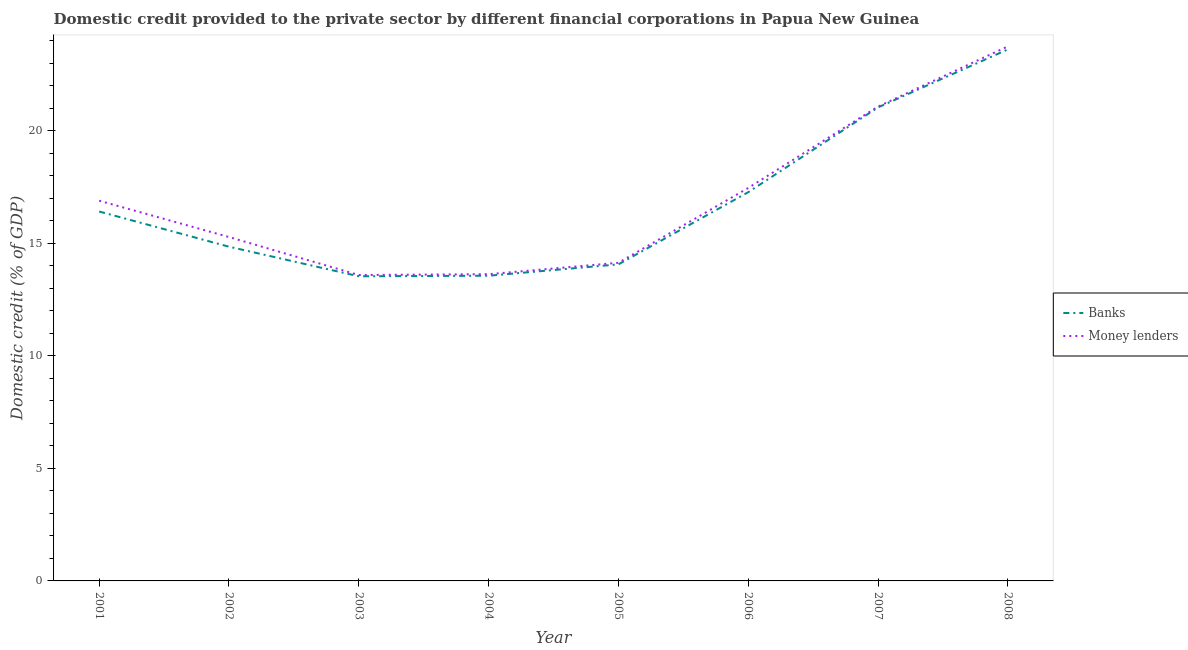Is the number of lines equal to the number of legend labels?
Make the answer very short. Yes. What is the domestic credit provided by money lenders in 2004?
Your answer should be compact. 13.62. Across all years, what is the maximum domestic credit provided by money lenders?
Offer a very short reply. 23.74. Across all years, what is the minimum domestic credit provided by money lenders?
Offer a terse response. 13.59. In which year was the domestic credit provided by money lenders maximum?
Your answer should be very brief. 2008. In which year was the domestic credit provided by banks minimum?
Your answer should be compact. 2003. What is the total domestic credit provided by banks in the graph?
Keep it short and to the point. 134.3. What is the difference between the domestic credit provided by money lenders in 2002 and that in 2008?
Give a very brief answer. -8.47. What is the difference between the domestic credit provided by money lenders in 2008 and the domestic credit provided by banks in 2002?
Offer a very short reply. 8.9. What is the average domestic credit provided by banks per year?
Ensure brevity in your answer.  16.79. In the year 2002, what is the difference between the domestic credit provided by money lenders and domestic credit provided by banks?
Your response must be concise. 0.43. In how many years, is the domestic credit provided by money lenders greater than 9 %?
Offer a terse response. 8. What is the ratio of the domestic credit provided by banks in 2002 to that in 2008?
Provide a short and direct response. 0.63. Is the difference between the domestic credit provided by money lenders in 2004 and 2005 greater than the difference between the domestic credit provided by banks in 2004 and 2005?
Offer a terse response. No. What is the difference between the highest and the second highest domestic credit provided by money lenders?
Keep it short and to the point. 2.67. What is the difference between the highest and the lowest domestic credit provided by banks?
Your answer should be compact. 10.08. Is the domestic credit provided by money lenders strictly greater than the domestic credit provided by banks over the years?
Offer a terse response. Yes. Are the values on the major ticks of Y-axis written in scientific E-notation?
Give a very brief answer. No. Does the graph contain any zero values?
Offer a terse response. No. How are the legend labels stacked?
Your answer should be very brief. Vertical. What is the title of the graph?
Offer a terse response. Domestic credit provided to the private sector by different financial corporations in Papua New Guinea. Does "Age 65(female)" appear as one of the legend labels in the graph?
Ensure brevity in your answer.  No. What is the label or title of the X-axis?
Provide a succinct answer. Year. What is the label or title of the Y-axis?
Provide a short and direct response. Domestic credit (% of GDP). What is the Domestic credit (% of GDP) in Banks in 2001?
Your answer should be compact. 16.41. What is the Domestic credit (% of GDP) of Money lenders in 2001?
Offer a very short reply. 16.89. What is the Domestic credit (% of GDP) in Banks in 2002?
Offer a very short reply. 14.84. What is the Domestic credit (% of GDP) in Money lenders in 2002?
Make the answer very short. 15.27. What is the Domestic credit (% of GDP) of Banks in 2003?
Provide a short and direct response. 13.53. What is the Domestic credit (% of GDP) in Money lenders in 2003?
Your answer should be very brief. 13.59. What is the Domestic credit (% of GDP) in Banks in 2004?
Your response must be concise. 13.56. What is the Domestic credit (% of GDP) in Money lenders in 2004?
Give a very brief answer. 13.62. What is the Domestic credit (% of GDP) in Banks in 2005?
Offer a very short reply. 14.06. What is the Domestic credit (% of GDP) of Money lenders in 2005?
Keep it short and to the point. 14.13. What is the Domestic credit (% of GDP) in Banks in 2006?
Provide a short and direct response. 17.27. What is the Domestic credit (% of GDP) in Money lenders in 2006?
Provide a short and direct response. 17.45. What is the Domestic credit (% of GDP) of Banks in 2007?
Provide a short and direct response. 21.03. What is the Domestic credit (% of GDP) in Money lenders in 2007?
Offer a very short reply. 21.07. What is the Domestic credit (% of GDP) in Banks in 2008?
Offer a very short reply. 23.61. What is the Domestic credit (% of GDP) in Money lenders in 2008?
Keep it short and to the point. 23.74. Across all years, what is the maximum Domestic credit (% of GDP) of Banks?
Offer a very short reply. 23.61. Across all years, what is the maximum Domestic credit (% of GDP) in Money lenders?
Provide a short and direct response. 23.74. Across all years, what is the minimum Domestic credit (% of GDP) in Banks?
Provide a succinct answer. 13.53. Across all years, what is the minimum Domestic credit (% of GDP) in Money lenders?
Give a very brief answer. 13.59. What is the total Domestic credit (% of GDP) in Banks in the graph?
Offer a very short reply. 134.3. What is the total Domestic credit (% of GDP) in Money lenders in the graph?
Give a very brief answer. 135.76. What is the difference between the Domestic credit (% of GDP) in Banks in 2001 and that in 2002?
Give a very brief answer. 1.56. What is the difference between the Domestic credit (% of GDP) of Money lenders in 2001 and that in 2002?
Your answer should be compact. 1.61. What is the difference between the Domestic credit (% of GDP) in Banks in 2001 and that in 2003?
Give a very brief answer. 2.88. What is the difference between the Domestic credit (% of GDP) of Banks in 2001 and that in 2004?
Provide a succinct answer. 2.85. What is the difference between the Domestic credit (% of GDP) in Money lenders in 2001 and that in 2004?
Your answer should be compact. 3.26. What is the difference between the Domestic credit (% of GDP) of Banks in 2001 and that in 2005?
Offer a very short reply. 2.35. What is the difference between the Domestic credit (% of GDP) of Money lenders in 2001 and that in 2005?
Your answer should be compact. 2.76. What is the difference between the Domestic credit (% of GDP) in Banks in 2001 and that in 2006?
Give a very brief answer. -0.86. What is the difference between the Domestic credit (% of GDP) of Money lenders in 2001 and that in 2006?
Offer a very short reply. -0.57. What is the difference between the Domestic credit (% of GDP) in Banks in 2001 and that in 2007?
Offer a very short reply. -4.62. What is the difference between the Domestic credit (% of GDP) of Money lenders in 2001 and that in 2007?
Offer a terse response. -4.18. What is the difference between the Domestic credit (% of GDP) in Banks in 2001 and that in 2008?
Make the answer very short. -7.2. What is the difference between the Domestic credit (% of GDP) of Money lenders in 2001 and that in 2008?
Give a very brief answer. -6.86. What is the difference between the Domestic credit (% of GDP) in Banks in 2002 and that in 2003?
Offer a very short reply. 1.31. What is the difference between the Domestic credit (% of GDP) of Money lenders in 2002 and that in 2003?
Offer a terse response. 1.69. What is the difference between the Domestic credit (% of GDP) of Banks in 2002 and that in 2004?
Provide a succinct answer. 1.29. What is the difference between the Domestic credit (% of GDP) of Money lenders in 2002 and that in 2004?
Give a very brief answer. 1.65. What is the difference between the Domestic credit (% of GDP) in Banks in 2002 and that in 2005?
Your answer should be compact. 0.78. What is the difference between the Domestic credit (% of GDP) in Money lenders in 2002 and that in 2005?
Your answer should be compact. 1.14. What is the difference between the Domestic credit (% of GDP) in Banks in 2002 and that in 2006?
Give a very brief answer. -2.42. What is the difference between the Domestic credit (% of GDP) of Money lenders in 2002 and that in 2006?
Make the answer very short. -2.18. What is the difference between the Domestic credit (% of GDP) in Banks in 2002 and that in 2007?
Offer a terse response. -6.19. What is the difference between the Domestic credit (% of GDP) of Money lenders in 2002 and that in 2007?
Give a very brief answer. -5.79. What is the difference between the Domestic credit (% of GDP) in Banks in 2002 and that in 2008?
Ensure brevity in your answer.  -8.76. What is the difference between the Domestic credit (% of GDP) in Money lenders in 2002 and that in 2008?
Provide a succinct answer. -8.47. What is the difference between the Domestic credit (% of GDP) of Banks in 2003 and that in 2004?
Ensure brevity in your answer.  -0.03. What is the difference between the Domestic credit (% of GDP) in Money lenders in 2003 and that in 2004?
Your response must be concise. -0.04. What is the difference between the Domestic credit (% of GDP) in Banks in 2003 and that in 2005?
Provide a short and direct response. -0.53. What is the difference between the Domestic credit (% of GDP) in Money lenders in 2003 and that in 2005?
Give a very brief answer. -0.54. What is the difference between the Domestic credit (% of GDP) of Banks in 2003 and that in 2006?
Give a very brief answer. -3.74. What is the difference between the Domestic credit (% of GDP) of Money lenders in 2003 and that in 2006?
Ensure brevity in your answer.  -3.87. What is the difference between the Domestic credit (% of GDP) in Banks in 2003 and that in 2007?
Keep it short and to the point. -7.5. What is the difference between the Domestic credit (% of GDP) of Money lenders in 2003 and that in 2007?
Your response must be concise. -7.48. What is the difference between the Domestic credit (% of GDP) in Banks in 2003 and that in 2008?
Provide a succinct answer. -10.08. What is the difference between the Domestic credit (% of GDP) in Money lenders in 2003 and that in 2008?
Your response must be concise. -10.16. What is the difference between the Domestic credit (% of GDP) in Banks in 2004 and that in 2005?
Provide a succinct answer. -0.5. What is the difference between the Domestic credit (% of GDP) of Money lenders in 2004 and that in 2005?
Your answer should be very brief. -0.51. What is the difference between the Domestic credit (% of GDP) in Banks in 2004 and that in 2006?
Give a very brief answer. -3.71. What is the difference between the Domestic credit (% of GDP) of Money lenders in 2004 and that in 2006?
Offer a terse response. -3.83. What is the difference between the Domestic credit (% of GDP) of Banks in 2004 and that in 2007?
Give a very brief answer. -7.48. What is the difference between the Domestic credit (% of GDP) of Money lenders in 2004 and that in 2007?
Your answer should be compact. -7.44. What is the difference between the Domestic credit (% of GDP) in Banks in 2004 and that in 2008?
Your response must be concise. -10.05. What is the difference between the Domestic credit (% of GDP) of Money lenders in 2004 and that in 2008?
Give a very brief answer. -10.12. What is the difference between the Domestic credit (% of GDP) of Banks in 2005 and that in 2006?
Make the answer very short. -3.21. What is the difference between the Domestic credit (% of GDP) of Money lenders in 2005 and that in 2006?
Your answer should be very brief. -3.32. What is the difference between the Domestic credit (% of GDP) of Banks in 2005 and that in 2007?
Your answer should be very brief. -6.97. What is the difference between the Domestic credit (% of GDP) in Money lenders in 2005 and that in 2007?
Keep it short and to the point. -6.94. What is the difference between the Domestic credit (% of GDP) of Banks in 2005 and that in 2008?
Make the answer very short. -9.55. What is the difference between the Domestic credit (% of GDP) in Money lenders in 2005 and that in 2008?
Ensure brevity in your answer.  -9.61. What is the difference between the Domestic credit (% of GDP) of Banks in 2006 and that in 2007?
Provide a short and direct response. -3.77. What is the difference between the Domestic credit (% of GDP) in Money lenders in 2006 and that in 2007?
Ensure brevity in your answer.  -3.62. What is the difference between the Domestic credit (% of GDP) of Banks in 2006 and that in 2008?
Make the answer very short. -6.34. What is the difference between the Domestic credit (% of GDP) of Money lenders in 2006 and that in 2008?
Make the answer very short. -6.29. What is the difference between the Domestic credit (% of GDP) of Banks in 2007 and that in 2008?
Your answer should be very brief. -2.58. What is the difference between the Domestic credit (% of GDP) of Money lenders in 2007 and that in 2008?
Your response must be concise. -2.67. What is the difference between the Domestic credit (% of GDP) in Banks in 2001 and the Domestic credit (% of GDP) in Money lenders in 2002?
Your answer should be compact. 1.13. What is the difference between the Domestic credit (% of GDP) in Banks in 2001 and the Domestic credit (% of GDP) in Money lenders in 2003?
Give a very brief answer. 2.82. What is the difference between the Domestic credit (% of GDP) of Banks in 2001 and the Domestic credit (% of GDP) of Money lenders in 2004?
Your answer should be compact. 2.78. What is the difference between the Domestic credit (% of GDP) of Banks in 2001 and the Domestic credit (% of GDP) of Money lenders in 2005?
Give a very brief answer. 2.28. What is the difference between the Domestic credit (% of GDP) of Banks in 2001 and the Domestic credit (% of GDP) of Money lenders in 2006?
Your answer should be compact. -1.05. What is the difference between the Domestic credit (% of GDP) in Banks in 2001 and the Domestic credit (% of GDP) in Money lenders in 2007?
Ensure brevity in your answer.  -4.66. What is the difference between the Domestic credit (% of GDP) in Banks in 2001 and the Domestic credit (% of GDP) in Money lenders in 2008?
Provide a succinct answer. -7.33. What is the difference between the Domestic credit (% of GDP) in Banks in 2002 and the Domestic credit (% of GDP) in Money lenders in 2003?
Ensure brevity in your answer.  1.26. What is the difference between the Domestic credit (% of GDP) in Banks in 2002 and the Domestic credit (% of GDP) in Money lenders in 2004?
Your answer should be compact. 1.22. What is the difference between the Domestic credit (% of GDP) of Banks in 2002 and the Domestic credit (% of GDP) of Money lenders in 2005?
Make the answer very short. 0.71. What is the difference between the Domestic credit (% of GDP) of Banks in 2002 and the Domestic credit (% of GDP) of Money lenders in 2006?
Your answer should be compact. -2.61. What is the difference between the Domestic credit (% of GDP) of Banks in 2002 and the Domestic credit (% of GDP) of Money lenders in 2007?
Keep it short and to the point. -6.22. What is the difference between the Domestic credit (% of GDP) of Banks in 2002 and the Domestic credit (% of GDP) of Money lenders in 2008?
Offer a very short reply. -8.9. What is the difference between the Domestic credit (% of GDP) of Banks in 2003 and the Domestic credit (% of GDP) of Money lenders in 2004?
Give a very brief answer. -0.09. What is the difference between the Domestic credit (% of GDP) in Banks in 2003 and the Domestic credit (% of GDP) in Money lenders in 2005?
Provide a short and direct response. -0.6. What is the difference between the Domestic credit (% of GDP) in Banks in 2003 and the Domestic credit (% of GDP) in Money lenders in 2006?
Offer a terse response. -3.92. What is the difference between the Domestic credit (% of GDP) in Banks in 2003 and the Domestic credit (% of GDP) in Money lenders in 2007?
Provide a short and direct response. -7.54. What is the difference between the Domestic credit (% of GDP) of Banks in 2003 and the Domestic credit (% of GDP) of Money lenders in 2008?
Provide a succinct answer. -10.21. What is the difference between the Domestic credit (% of GDP) of Banks in 2004 and the Domestic credit (% of GDP) of Money lenders in 2005?
Offer a terse response. -0.57. What is the difference between the Domestic credit (% of GDP) in Banks in 2004 and the Domestic credit (% of GDP) in Money lenders in 2006?
Offer a very short reply. -3.9. What is the difference between the Domestic credit (% of GDP) of Banks in 2004 and the Domestic credit (% of GDP) of Money lenders in 2007?
Keep it short and to the point. -7.51. What is the difference between the Domestic credit (% of GDP) in Banks in 2004 and the Domestic credit (% of GDP) in Money lenders in 2008?
Offer a very short reply. -10.19. What is the difference between the Domestic credit (% of GDP) of Banks in 2005 and the Domestic credit (% of GDP) of Money lenders in 2006?
Your answer should be very brief. -3.39. What is the difference between the Domestic credit (% of GDP) in Banks in 2005 and the Domestic credit (% of GDP) in Money lenders in 2007?
Give a very brief answer. -7.01. What is the difference between the Domestic credit (% of GDP) of Banks in 2005 and the Domestic credit (% of GDP) of Money lenders in 2008?
Your answer should be compact. -9.68. What is the difference between the Domestic credit (% of GDP) of Banks in 2006 and the Domestic credit (% of GDP) of Money lenders in 2007?
Give a very brief answer. -3.8. What is the difference between the Domestic credit (% of GDP) in Banks in 2006 and the Domestic credit (% of GDP) in Money lenders in 2008?
Keep it short and to the point. -6.48. What is the difference between the Domestic credit (% of GDP) of Banks in 2007 and the Domestic credit (% of GDP) of Money lenders in 2008?
Provide a succinct answer. -2.71. What is the average Domestic credit (% of GDP) in Banks per year?
Your response must be concise. 16.79. What is the average Domestic credit (% of GDP) in Money lenders per year?
Offer a very short reply. 16.97. In the year 2001, what is the difference between the Domestic credit (% of GDP) of Banks and Domestic credit (% of GDP) of Money lenders?
Your answer should be compact. -0.48. In the year 2002, what is the difference between the Domestic credit (% of GDP) of Banks and Domestic credit (% of GDP) of Money lenders?
Make the answer very short. -0.43. In the year 2003, what is the difference between the Domestic credit (% of GDP) of Banks and Domestic credit (% of GDP) of Money lenders?
Provide a short and direct response. -0.06. In the year 2004, what is the difference between the Domestic credit (% of GDP) in Banks and Domestic credit (% of GDP) in Money lenders?
Keep it short and to the point. -0.07. In the year 2005, what is the difference between the Domestic credit (% of GDP) in Banks and Domestic credit (% of GDP) in Money lenders?
Ensure brevity in your answer.  -0.07. In the year 2006, what is the difference between the Domestic credit (% of GDP) of Banks and Domestic credit (% of GDP) of Money lenders?
Give a very brief answer. -0.19. In the year 2007, what is the difference between the Domestic credit (% of GDP) in Banks and Domestic credit (% of GDP) in Money lenders?
Ensure brevity in your answer.  -0.04. In the year 2008, what is the difference between the Domestic credit (% of GDP) of Banks and Domestic credit (% of GDP) of Money lenders?
Provide a short and direct response. -0.13. What is the ratio of the Domestic credit (% of GDP) of Banks in 2001 to that in 2002?
Offer a terse response. 1.11. What is the ratio of the Domestic credit (% of GDP) of Money lenders in 2001 to that in 2002?
Provide a short and direct response. 1.11. What is the ratio of the Domestic credit (% of GDP) of Banks in 2001 to that in 2003?
Provide a succinct answer. 1.21. What is the ratio of the Domestic credit (% of GDP) of Money lenders in 2001 to that in 2003?
Make the answer very short. 1.24. What is the ratio of the Domestic credit (% of GDP) in Banks in 2001 to that in 2004?
Offer a terse response. 1.21. What is the ratio of the Domestic credit (% of GDP) of Money lenders in 2001 to that in 2004?
Offer a very short reply. 1.24. What is the ratio of the Domestic credit (% of GDP) of Banks in 2001 to that in 2005?
Provide a short and direct response. 1.17. What is the ratio of the Domestic credit (% of GDP) in Money lenders in 2001 to that in 2005?
Ensure brevity in your answer.  1.2. What is the ratio of the Domestic credit (% of GDP) of Banks in 2001 to that in 2006?
Keep it short and to the point. 0.95. What is the ratio of the Domestic credit (% of GDP) of Money lenders in 2001 to that in 2006?
Offer a terse response. 0.97. What is the ratio of the Domestic credit (% of GDP) of Banks in 2001 to that in 2007?
Provide a succinct answer. 0.78. What is the ratio of the Domestic credit (% of GDP) of Money lenders in 2001 to that in 2007?
Make the answer very short. 0.8. What is the ratio of the Domestic credit (% of GDP) of Banks in 2001 to that in 2008?
Keep it short and to the point. 0.69. What is the ratio of the Domestic credit (% of GDP) in Money lenders in 2001 to that in 2008?
Offer a very short reply. 0.71. What is the ratio of the Domestic credit (% of GDP) of Banks in 2002 to that in 2003?
Make the answer very short. 1.1. What is the ratio of the Domestic credit (% of GDP) of Money lenders in 2002 to that in 2003?
Keep it short and to the point. 1.12. What is the ratio of the Domestic credit (% of GDP) of Banks in 2002 to that in 2004?
Keep it short and to the point. 1.1. What is the ratio of the Domestic credit (% of GDP) of Money lenders in 2002 to that in 2004?
Your answer should be very brief. 1.12. What is the ratio of the Domestic credit (% of GDP) in Banks in 2002 to that in 2005?
Provide a short and direct response. 1.06. What is the ratio of the Domestic credit (% of GDP) in Money lenders in 2002 to that in 2005?
Your answer should be very brief. 1.08. What is the ratio of the Domestic credit (% of GDP) of Banks in 2002 to that in 2006?
Give a very brief answer. 0.86. What is the ratio of the Domestic credit (% of GDP) of Money lenders in 2002 to that in 2006?
Your answer should be very brief. 0.88. What is the ratio of the Domestic credit (% of GDP) of Banks in 2002 to that in 2007?
Offer a very short reply. 0.71. What is the ratio of the Domestic credit (% of GDP) in Money lenders in 2002 to that in 2007?
Give a very brief answer. 0.72. What is the ratio of the Domestic credit (% of GDP) in Banks in 2002 to that in 2008?
Offer a terse response. 0.63. What is the ratio of the Domestic credit (% of GDP) in Money lenders in 2002 to that in 2008?
Your answer should be very brief. 0.64. What is the ratio of the Domestic credit (% of GDP) of Banks in 2003 to that in 2004?
Provide a succinct answer. 1. What is the ratio of the Domestic credit (% of GDP) of Money lenders in 2003 to that in 2004?
Ensure brevity in your answer.  1. What is the ratio of the Domestic credit (% of GDP) of Banks in 2003 to that in 2005?
Your response must be concise. 0.96. What is the ratio of the Domestic credit (% of GDP) in Money lenders in 2003 to that in 2005?
Make the answer very short. 0.96. What is the ratio of the Domestic credit (% of GDP) in Banks in 2003 to that in 2006?
Make the answer very short. 0.78. What is the ratio of the Domestic credit (% of GDP) of Money lenders in 2003 to that in 2006?
Your response must be concise. 0.78. What is the ratio of the Domestic credit (% of GDP) in Banks in 2003 to that in 2007?
Keep it short and to the point. 0.64. What is the ratio of the Domestic credit (% of GDP) of Money lenders in 2003 to that in 2007?
Keep it short and to the point. 0.64. What is the ratio of the Domestic credit (% of GDP) of Banks in 2003 to that in 2008?
Your response must be concise. 0.57. What is the ratio of the Domestic credit (% of GDP) in Money lenders in 2003 to that in 2008?
Provide a short and direct response. 0.57. What is the ratio of the Domestic credit (% of GDP) of Banks in 2004 to that in 2005?
Your response must be concise. 0.96. What is the ratio of the Domestic credit (% of GDP) of Money lenders in 2004 to that in 2005?
Make the answer very short. 0.96. What is the ratio of the Domestic credit (% of GDP) of Banks in 2004 to that in 2006?
Your answer should be very brief. 0.79. What is the ratio of the Domestic credit (% of GDP) in Money lenders in 2004 to that in 2006?
Give a very brief answer. 0.78. What is the ratio of the Domestic credit (% of GDP) in Banks in 2004 to that in 2007?
Offer a very short reply. 0.64. What is the ratio of the Domestic credit (% of GDP) in Money lenders in 2004 to that in 2007?
Provide a succinct answer. 0.65. What is the ratio of the Domestic credit (% of GDP) in Banks in 2004 to that in 2008?
Your response must be concise. 0.57. What is the ratio of the Domestic credit (% of GDP) of Money lenders in 2004 to that in 2008?
Ensure brevity in your answer.  0.57. What is the ratio of the Domestic credit (% of GDP) of Banks in 2005 to that in 2006?
Offer a terse response. 0.81. What is the ratio of the Domestic credit (% of GDP) of Money lenders in 2005 to that in 2006?
Your answer should be very brief. 0.81. What is the ratio of the Domestic credit (% of GDP) in Banks in 2005 to that in 2007?
Give a very brief answer. 0.67. What is the ratio of the Domestic credit (% of GDP) of Money lenders in 2005 to that in 2007?
Offer a terse response. 0.67. What is the ratio of the Domestic credit (% of GDP) of Banks in 2005 to that in 2008?
Your answer should be compact. 0.6. What is the ratio of the Domestic credit (% of GDP) of Money lenders in 2005 to that in 2008?
Provide a short and direct response. 0.6. What is the ratio of the Domestic credit (% of GDP) in Banks in 2006 to that in 2007?
Provide a succinct answer. 0.82. What is the ratio of the Domestic credit (% of GDP) of Money lenders in 2006 to that in 2007?
Give a very brief answer. 0.83. What is the ratio of the Domestic credit (% of GDP) in Banks in 2006 to that in 2008?
Make the answer very short. 0.73. What is the ratio of the Domestic credit (% of GDP) in Money lenders in 2006 to that in 2008?
Keep it short and to the point. 0.74. What is the ratio of the Domestic credit (% of GDP) of Banks in 2007 to that in 2008?
Your response must be concise. 0.89. What is the ratio of the Domestic credit (% of GDP) in Money lenders in 2007 to that in 2008?
Provide a short and direct response. 0.89. What is the difference between the highest and the second highest Domestic credit (% of GDP) of Banks?
Give a very brief answer. 2.58. What is the difference between the highest and the second highest Domestic credit (% of GDP) of Money lenders?
Your response must be concise. 2.67. What is the difference between the highest and the lowest Domestic credit (% of GDP) in Banks?
Ensure brevity in your answer.  10.08. What is the difference between the highest and the lowest Domestic credit (% of GDP) in Money lenders?
Ensure brevity in your answer.  10.16. 